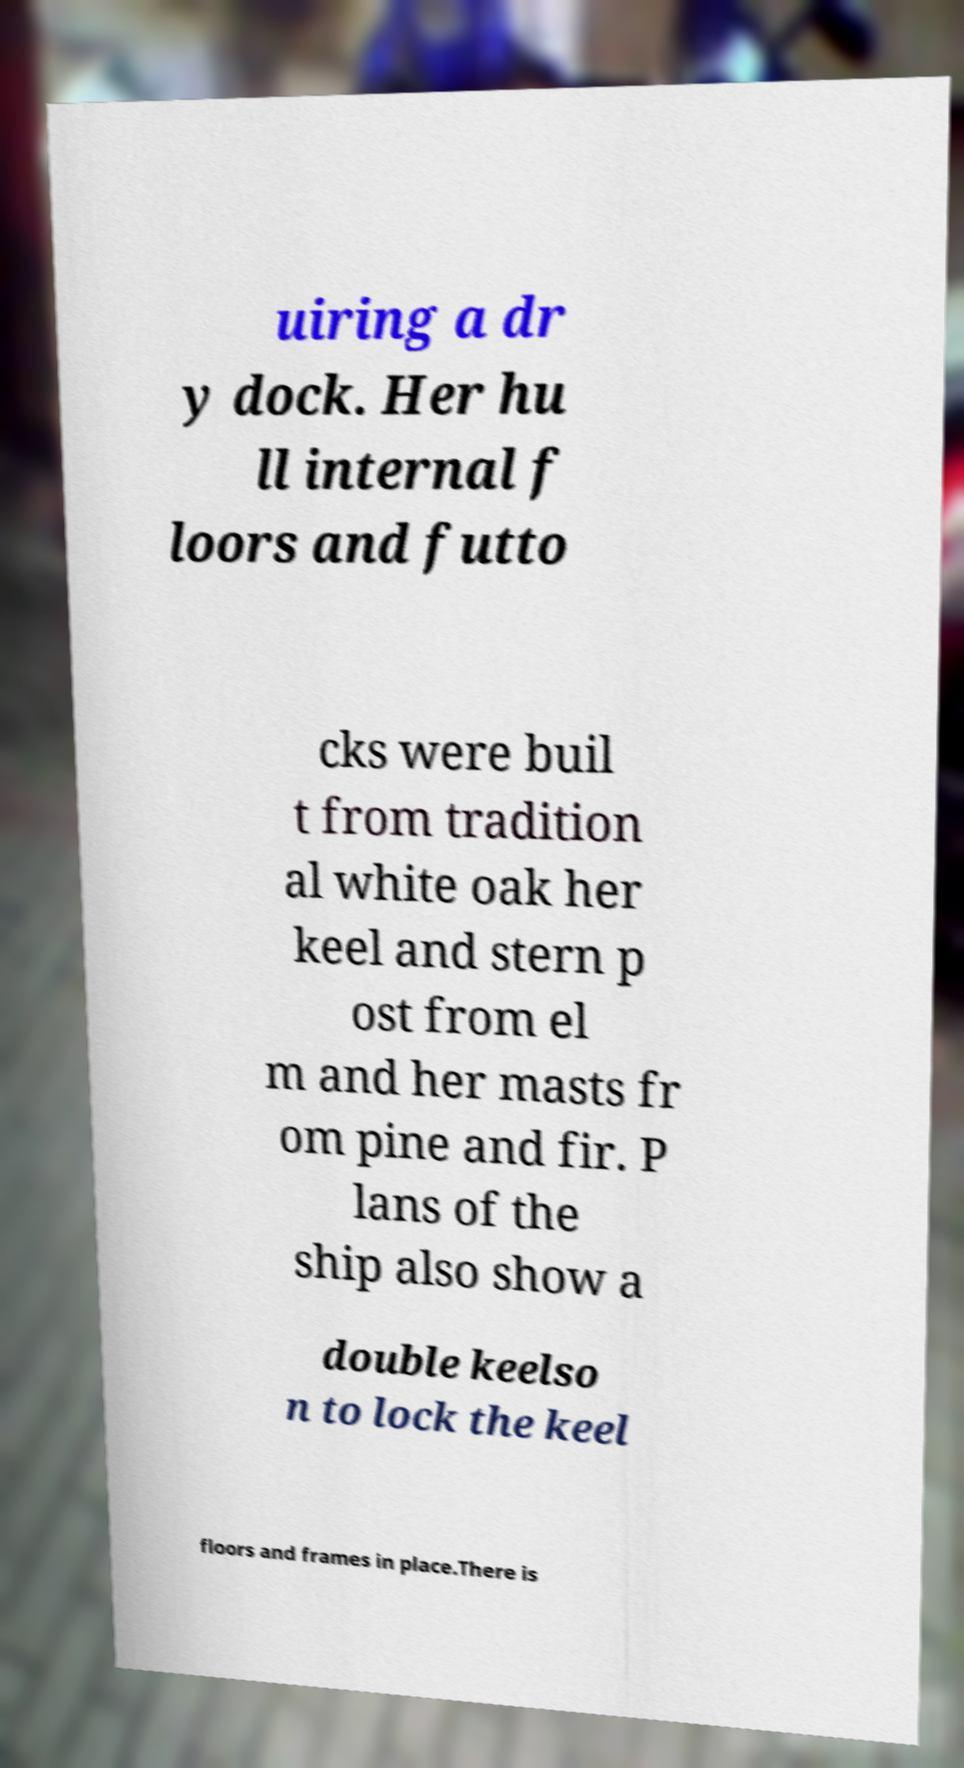Please read and relay the text visible in this image. What does it say? uiring a dr y dock. Her hu ll internal f loors and futto cks were buil t from tradition al white oak her keel and stern p ost from el m and her masts fr om pine and fir. P lans of the ship also show a double keelso n to lock the keel floors and frames in place.There is 